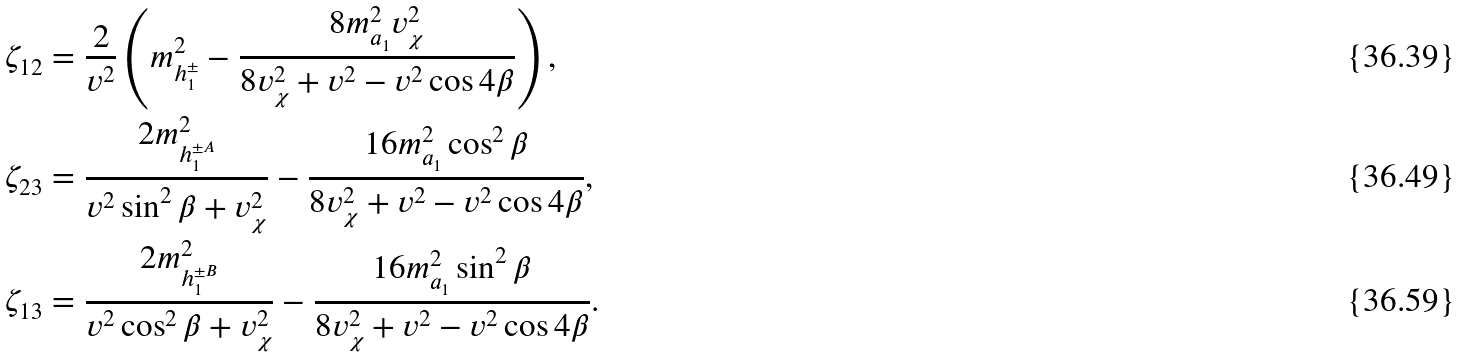<formula> <loc_0><loc_0><loc_500><loc_500>\zeta _ { 1 2 } & = \frac { 2 } { v ^ { 2 } } \left ( m _ { h _ { 1 } ^ { \pm } } ^ { 2 } - \frac { 8 m _ { a _ { 1 } } ^ { 2 } v _ { \chi } ^ { 2 } } { 8 v _ { \chi } ^ { 2 } + v ^ { 2 } - v ^ { 2 } \cos 4 \beta } \right ) , \\ \zeta _ { 2 3 } & = \frac { 2 m ^ { 2 } _ { h _ { 1 } ^ { \pm A } } } { v ^ { 2 } \sin ^ { 2 } \beta + v _ { \chi } ^ { 2 } } - \frac { 1 6 m _ { a _ { 1 } } ^ { 2 } \cos ^ { 2 } \beta } { 8 v _ { \chi } ^ { 2 } + v ^ { 2 } - v ^ { 2 } \cos 4 \beta } , \\ \zeta _ { 1 3 } & = \frac { 2 m ^ { 2 } _ { h _ { 1 } ^ { \pm B } } } { v ^ { 2 } \cos ^ { 2 } \beta + v _ { \chi } ^ { 2 } } - \frac { 1 6 m _ { a _ { 1 } } ^ { 2 } \sin ^ { 2 } \beta } { 8 v _ { \chi } ^ { 2 } + v ^ { 2 } - v ^ { 2 } \cos 4 \beta } .</formula> 